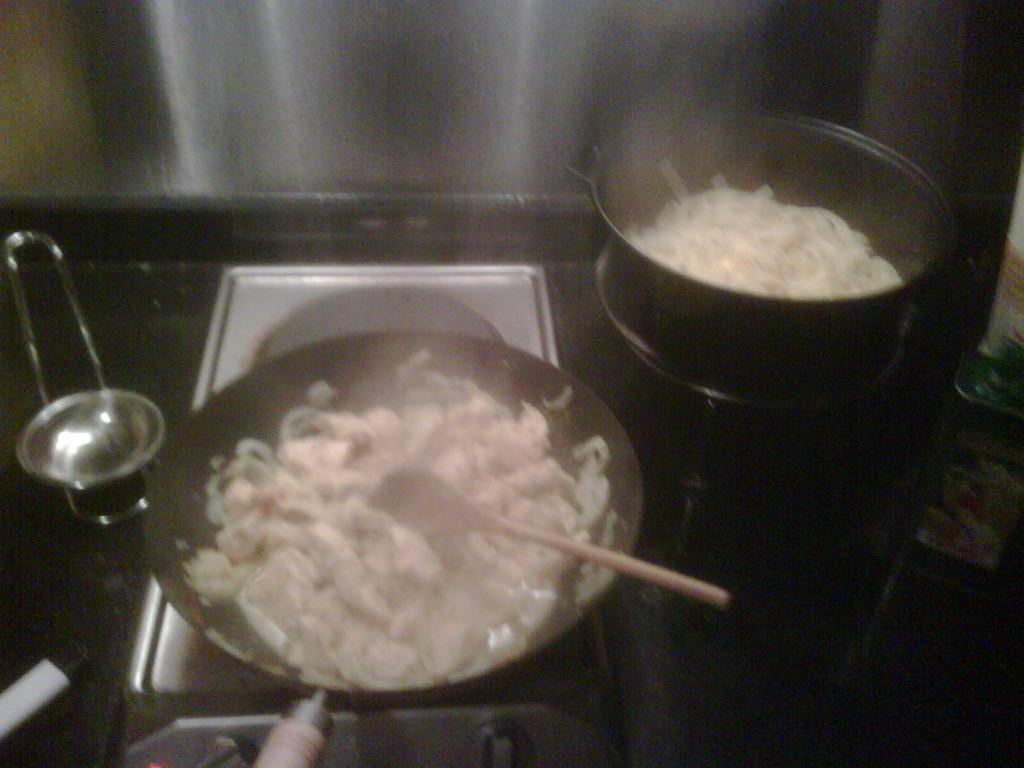What objects are on the stoves in the image? There are utensils on the stoves in the image. What is inside the utensils? The utensils contain food items. Can you describe the wooden spatula in the image? The wooden spatula is in a vessel. What type of payment method is accepted for the food items in the image? There is no information about payment methods in the image, as it only shows utensils containing food items and a wooden spatula in a vessel. 